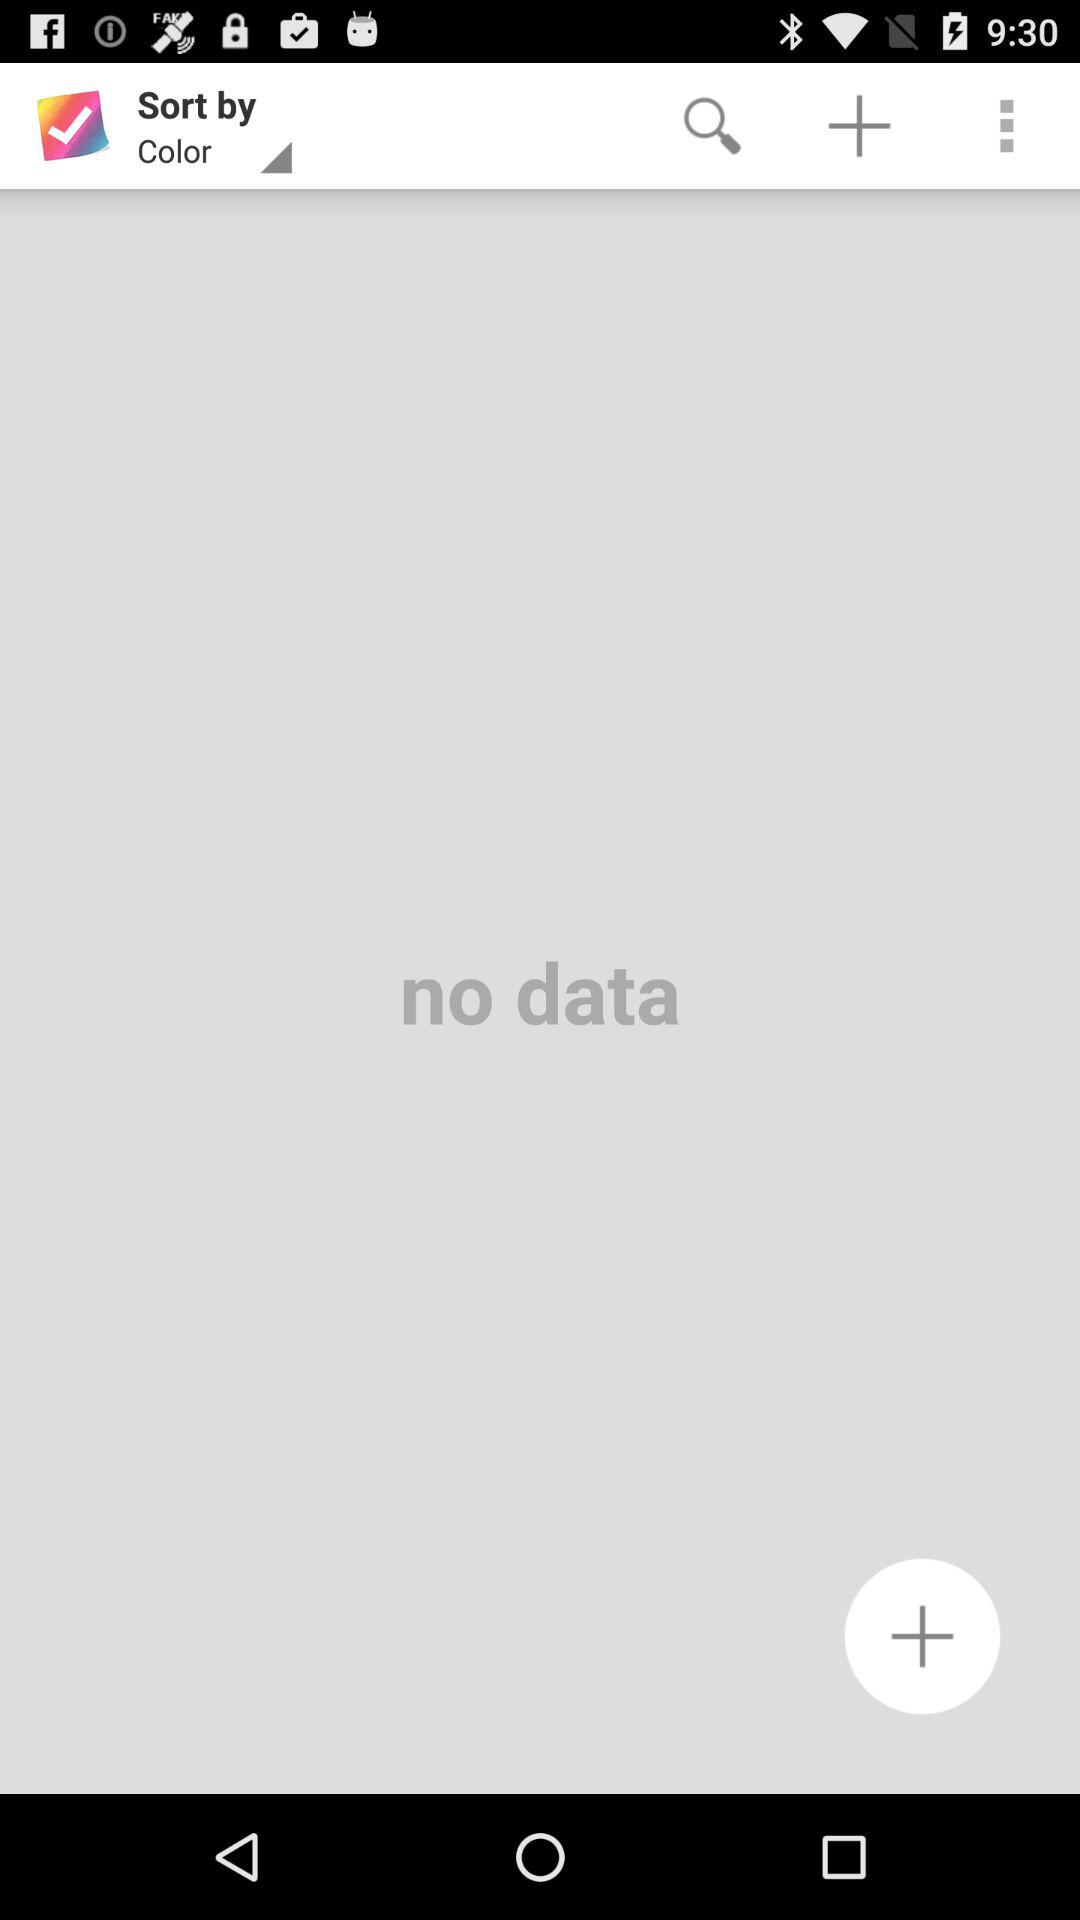Is there any data? There is no data. 